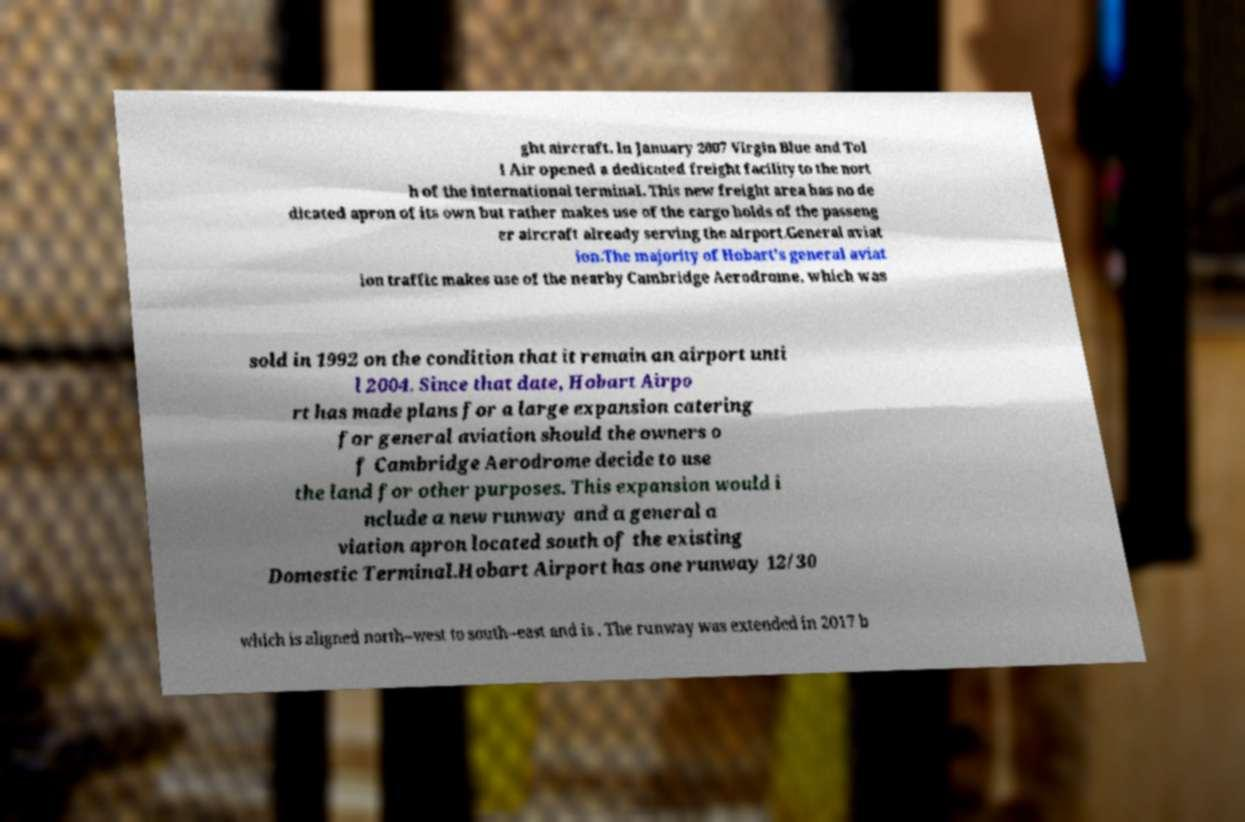Can you read and provide the text displayed in the image?This photo seems to have some interesting text. Can you extract and type it out for me? ght aircraft. In January 2007 Virgin Blue and Tol l Air opened a dedicated freight facility to the nort h of the international terminal. This new freight area has no de dicated apron of its own but rather makes use of the cargo holds of the passeng er aircraft already serving the airport.General aviat ion.The majority of Hobart's general aviat ion traffic makes use of the nearby Cambridge Aerodrome, which was sold in 1992 on the condition that it remain an airport unti l 2004. Since that date, Hobart Airpo rt has made plans for a large expansion catering for general aviation should the owners o f Cambridge Aerodrome decide to use the land for other purposes. This expansion would i nclude a new runway and a general a viation apron located south of the existing Domestic Terminal.Hobart Airport has one runway 12/30 which is aligned north–west to south–east and is . The runway was extended in 2017 b 